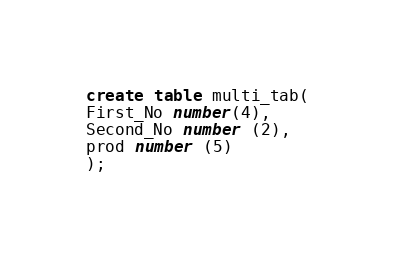<code> <loc_0><loc_0><loc_500><loc_500><_SQL_>create table multi_tab(
First_No number(4),
Second_No number (2),
prod number (5)
);</code> 